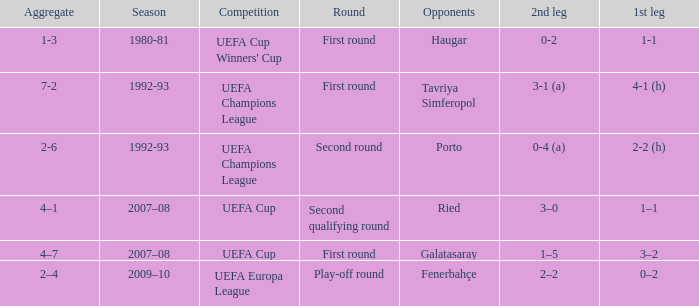What is the total number of 2nd leg where aggregate is 7-2 1.0. 